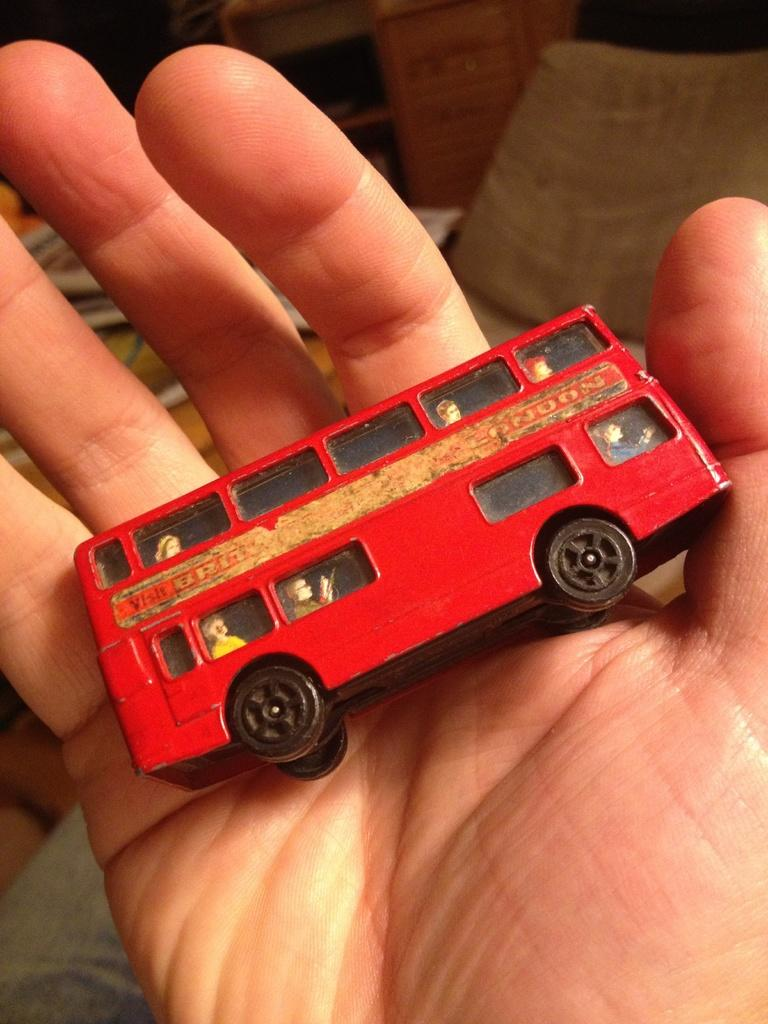What is the main focus of the image? The main focus of the image is a person's hand. What is the hand holding? The hand is holding a toy. What can be seen in the background of the image? In the background of the image, there are books, a chair, a cupboard, and some unspecified objects. Can you see any boats in the harbor in the image? There is no harbor or boats present in the image; it features a person's hand holding a toy and various objects in the background. 